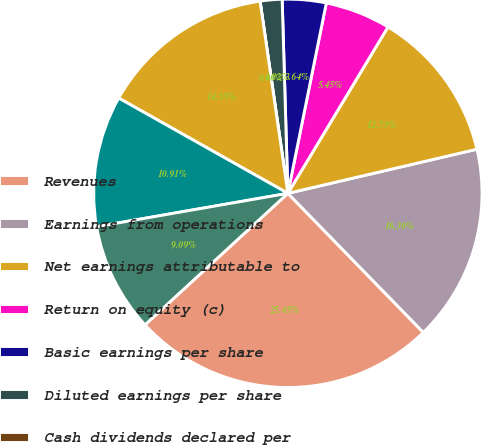<chart> <loc_0><loc_0><loc_500><loc_500><pie_chart><fcel>Revenues<fcel>Earnings from operations<fcel>Net earnings attributable to<fcel>Return on equity (c)<fcel>Basic earnings per share<fcel>Diluted earnings per share<fcel>Cash dividends declared per<fcel>Operating activities<fcel>Investing activities<fcel>Financing activities<nl><fcel>25.45%<fcel>16.36%<fcel>12.73%<fcel>5.45%<fcel>3.64%<fcel>1.82%<fcel>0.0%<fcel>14.55%<fcel>10.91%<fcel>9.09%<nl></chart> 